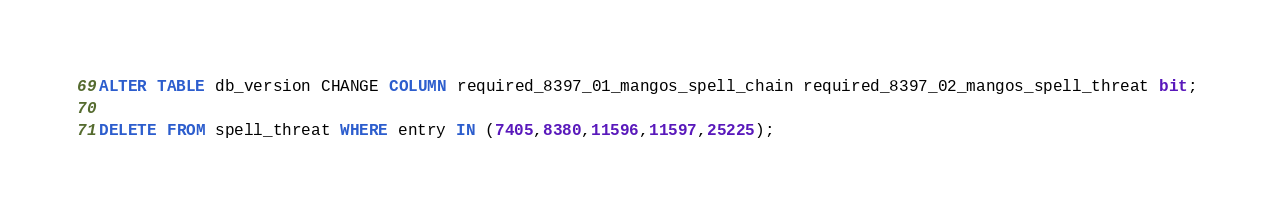Convert code to text. <code><loc_0><loc_0><loc_500><loc_500><_SQL_>ALTER TABLE db_version CHANGE COLUMN required_8397_01_mangos_spell_chain required_8397_02_mangos_spell_threat bit;

DELETE FROM spell_threat WHERE entry IN (7405,8380,11596,11597,25225);
</code> 